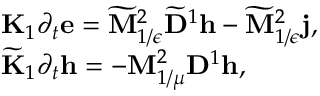Convert formula to latex. <formula><loc_0><loc_0><loc_500><loc_500>\begin{array} { r l } & { { K } _ { 1 } \partial _ { t } e = \widetilde { M } _ { 1 / \epsilon } ^ { 2 } \widetilde { D } ^ { 1 } h - \widetilde { M } _ { 1 / \epsilon } ^ { 2 } j , } \\ & { \widetilde { K } _ { 1 } \partial _ { t } h = - M _ { 1 / \mu } ^ { 2 } D ^ { 1 } h , } \end{array}</formula> 